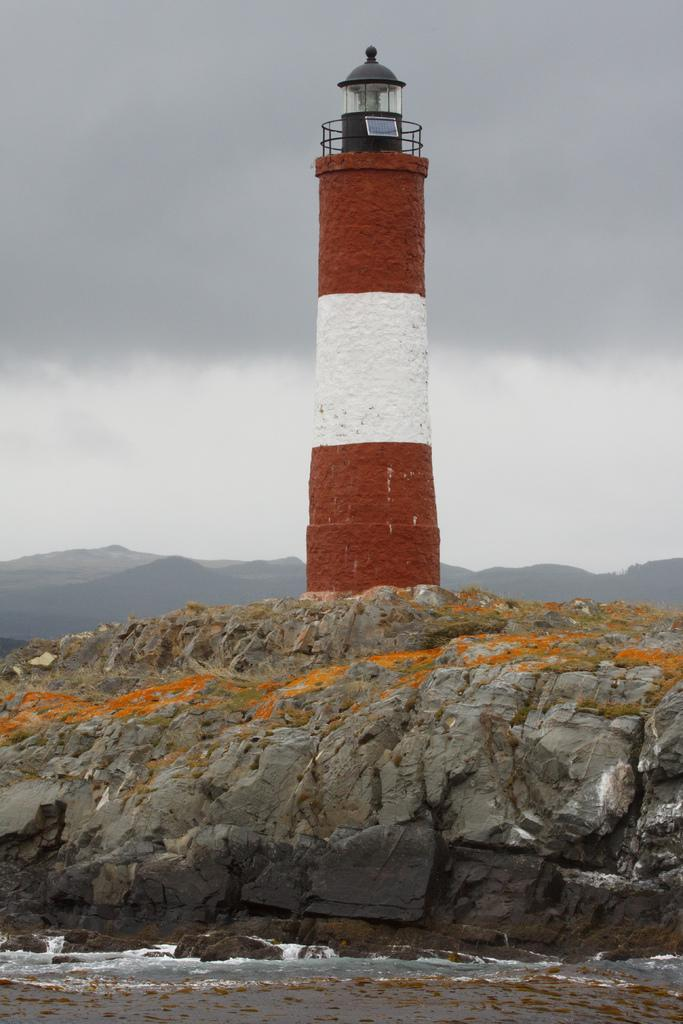What can be seen near the big rocks in the image? There is water near the big rocks in the image. What structure is visible in the image? There is a tower in the image. What type of natural formation can be seen in the background of the image? There are mountains in the background of the image. What is visible in the sky in the background of the image? There are clouds in the sky in the background of the image. What size of rocks can be seen sorting themselves in the image? There are no rocks sorting themselves in the image; the rocks are near water and are not involved in any sorting activity. What shade of clouds can be seen in the image? The provided facts do not mention the shade of the clouds; only their presence is mentioned. 